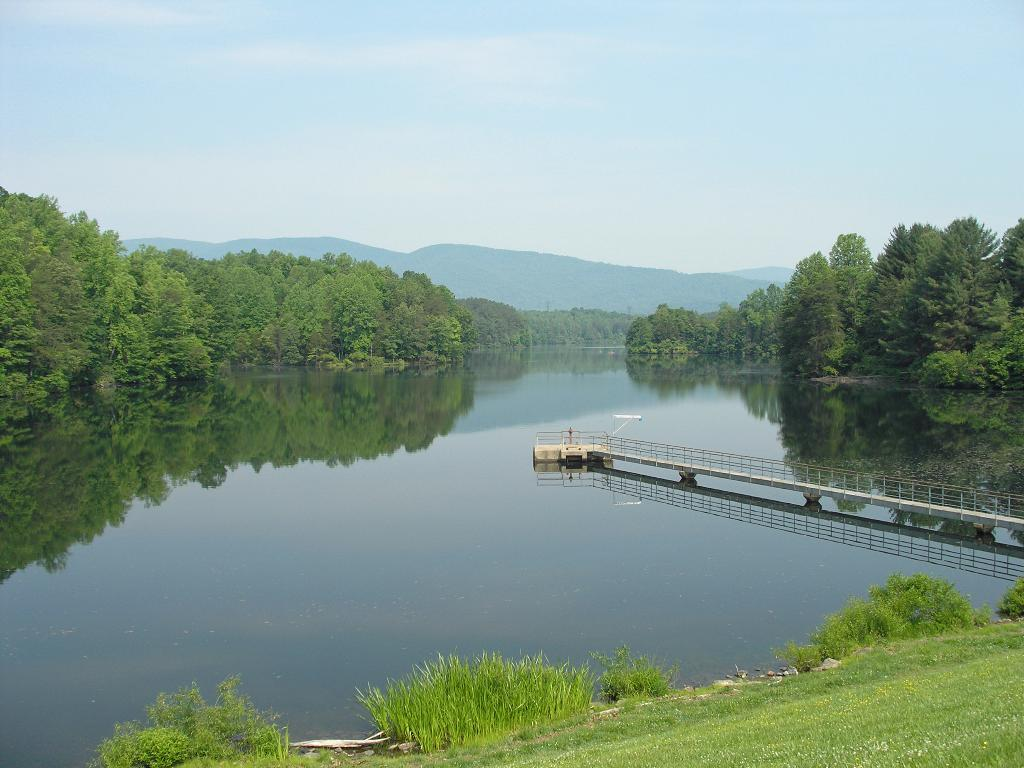What can be seen in the sky in the image? The sky with clouds is visible in the image. What type of vegetation is present in the image? There are trees, shrubs, and bushes in the image. What type of landform is present in the image? Hills are present in the image. What type of structure is visible in the image? There is a small bridge in the image. What body of water is visible in the image? A lake is visible in the image. What is visible on the ground in the image? The ground is visible in the image. What note is being played by the control panel in the image? There is no control panel or note present in the image. 